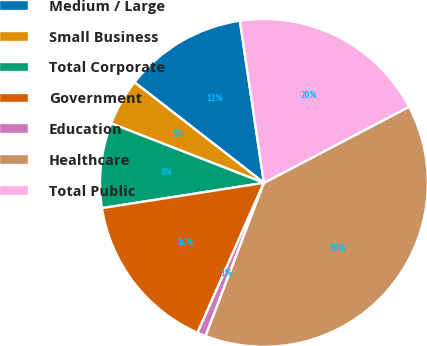Convert chart. <chart><loc_0><loc_0><loc_500><loc_500><pie_chart><fcel>Medium / Large<fcel>Small Business<fcel>Total Corporate<fcel>Government<fcel>Education<fcel>Healthcare<fcel>Total Public<nl><fcel>12.14%<fcel>4.61%<fcel>8.37%<fcel>15.9%<fcel>0.85%<fcel>38.47%<fcel>19.66%<nl></chart> 